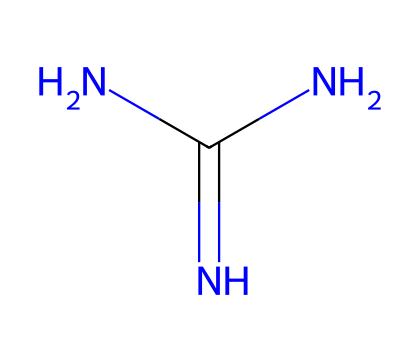What is the name of the chemical represented by this SMILES? The SMILES representation NC(=N)N corresponds to guanidine, which is a well-known compound in organic chemistry. The elements present in the structure indicate it is a derivative of urea.
Answer: guanidine How many nitrogen atoms are in this chemical? From the SMILES representation, we can see three nitrogen atoms (N) present in the molecular structure of guanidine.
Answer: three What type of bonding is primarily present in guanidine? The bonds in guanidine consist of both single bonds and one double bond, indicating it has both types of bonding, but given its functional properties, it is primarily characterized by hydrogen bonding capabilities associated with its amine groups.
Answer: hydrogen bonding What is the functional group present in guanidine? Analyzing the structure, we identify the functional group in guanidine, which is an amine group due to the presence of nitrogen atoms connected to hydrogen atoms.
Answer: amine Why could guanidine be considered a superbase? Guanidine has a high basicity due to the presence of three nitrogen atoms, which can easily donate electron pairs, thus making it a potent superbase that can deprotonate compounds more effectively than many other bases.
Answer: high basicity What type of reactions can guanidine readily participate in? Guanidine’s structure allows it to engage in nucleophilic substitution reactions due to its nitrogen atoms being good nucleophiles; also, it can act as a strong base in proton transfer reactions.
Answer: nucleophilic substitution 